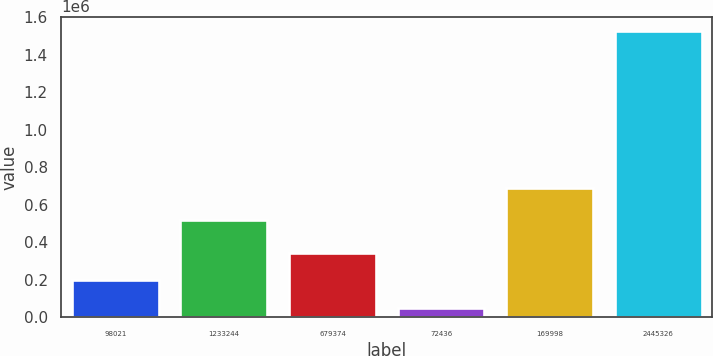Convert chart to OTSL. <chart><loc_0><loc_0><loc_500><loc_500><bar_chart><fcel>98021<fcel>1233244<fcel>679374<fcel>72436<fcel>169998<fcel>2445326<nl><fcel>198053<fcel>518613<fcel>345587<fcel>50518<fcel>689015<fcel>1.52586e+06<nl></chart> 